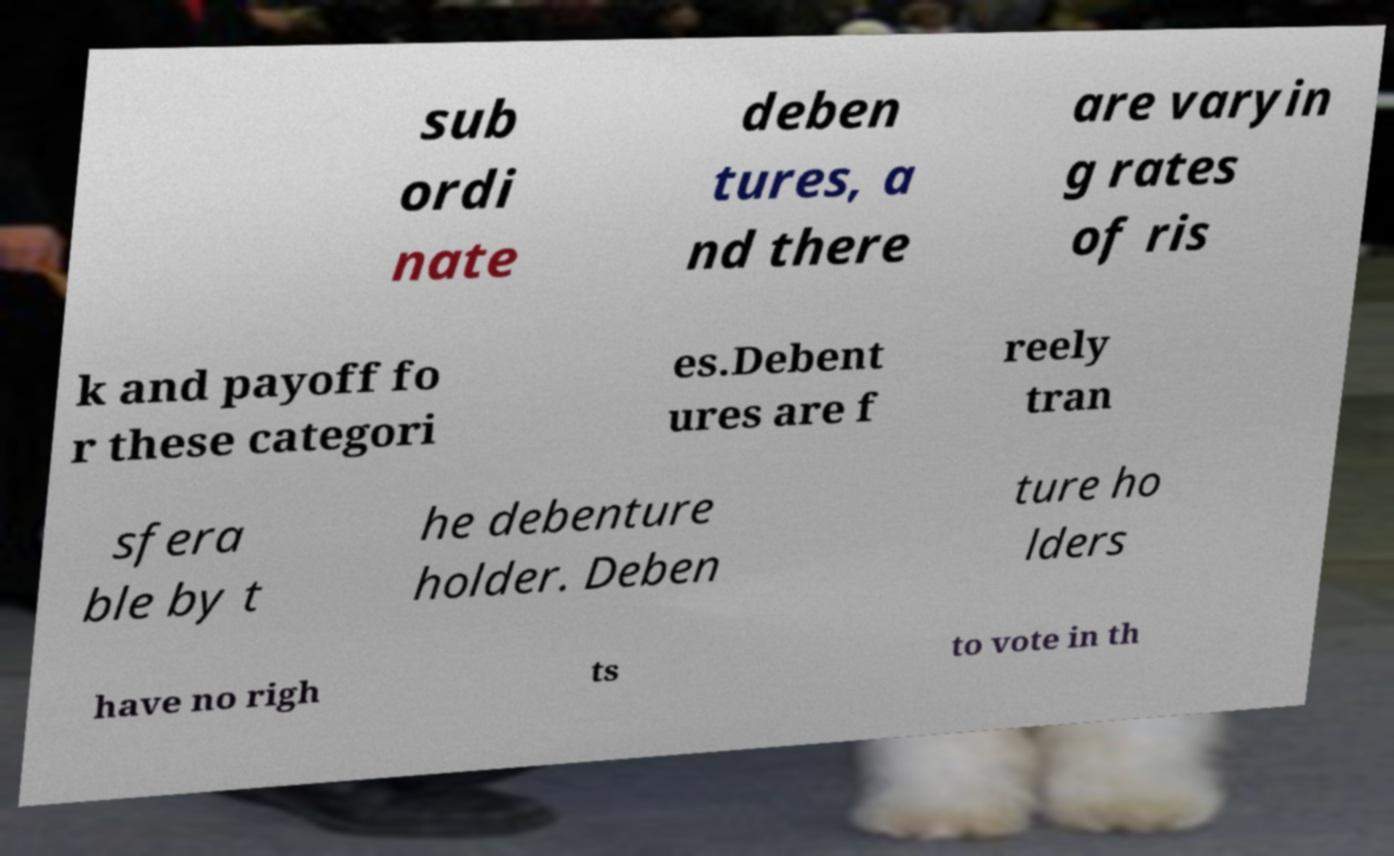For documentation purposes, I need the text within this image transcribed. Could you provide that? sub ordi nate deben tures, a nd there are varyin g rates of ris k and payoff fo r these categori es.Debent ures are f reely tran sfera ble by t he debenture holder. Deben ture ho lders have no righ ts to vote in th 